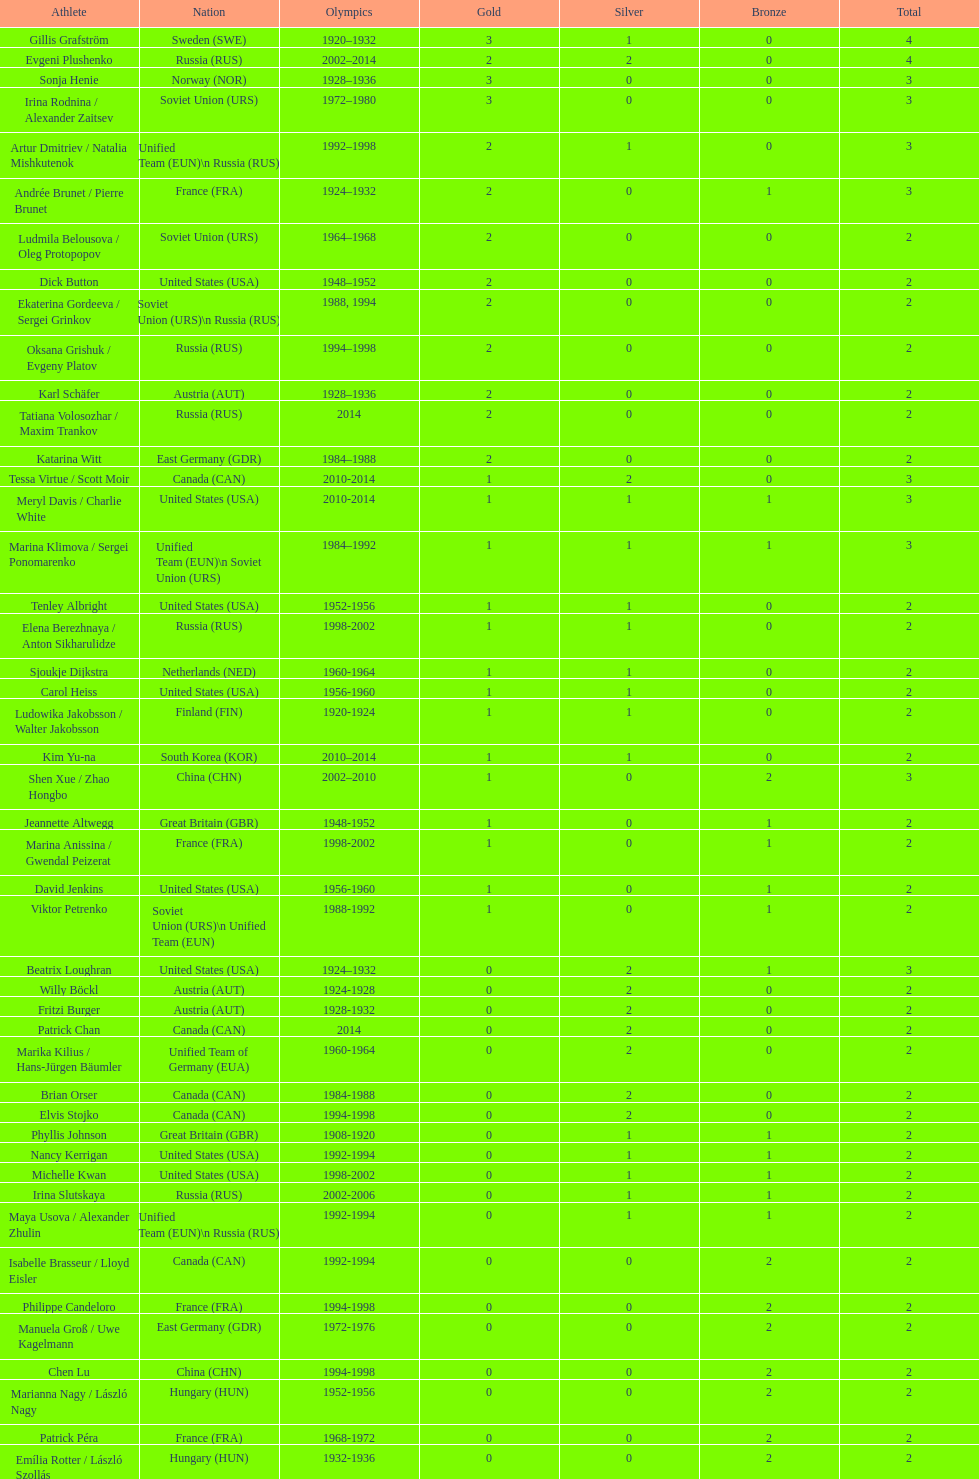Which country initially achieved three olympic gold medals in figure skating? Sweden. 